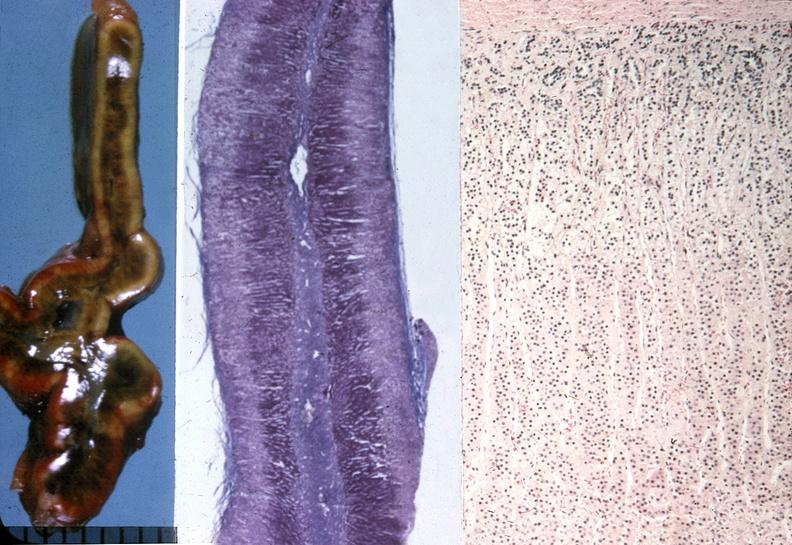does this typical lesion show adrenal, cushing syndrome?
Answer the question using a single word or phrase. No 